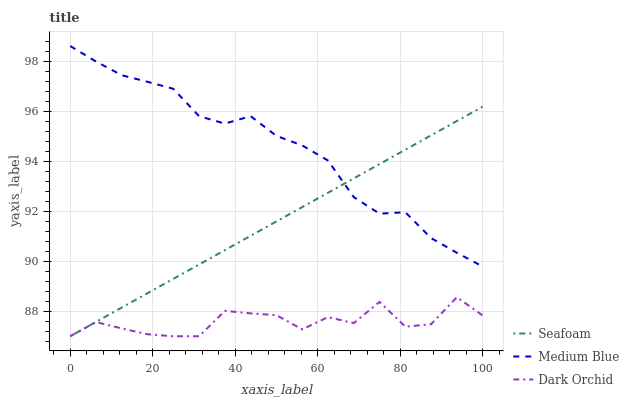Does Dark Orchid have the minimum area under the curve?
Answer yes or no. Yes. Does Medium Blue have the maximum area under the curve?
Answer yes or no. Yes. Does Seafoam have the minimum area under the curve?
Answer yes or no. No. Does Seafoam have the maximum area under the curve?
Answer yes or no. No. Is Seafoam the smoothest?
Answer yes or no. Yes. Is Dark Orchid the roughest?
Answer yes or no. Yes. Is Dark Orchid the smoothest?
Answer yes or no. No. Is Seafoam the roughest?
Answer yes or no. No. Does Seafoam have the lowest value?
Answer yes or no. Yes. Does Medium Blue have the highest value?
Answer yes or no. Yes. Does Seafoam have the highest value?
Answer yes or no. No. Is Dark Orchid less than Medium Blue?
Answer yes or no. Yes. Is Medium Blue greater than Dark Orchid?
Answer yes or no. Yes. Does Medium Blue intersect Seafoam?
Answer yes or no. Yes. Is Medium Blue less than Seafoam?
Answer yes or no. No. Is Medium Blue greater than Seafoam?
Answer yes or no. No. Does Dark Orchid intersect Medium Blue?
Answer yes or no. No. 